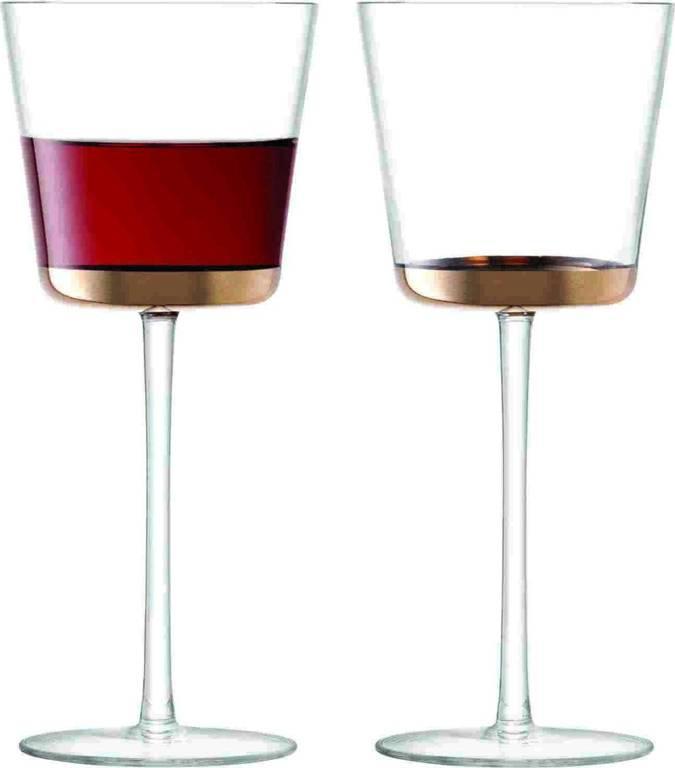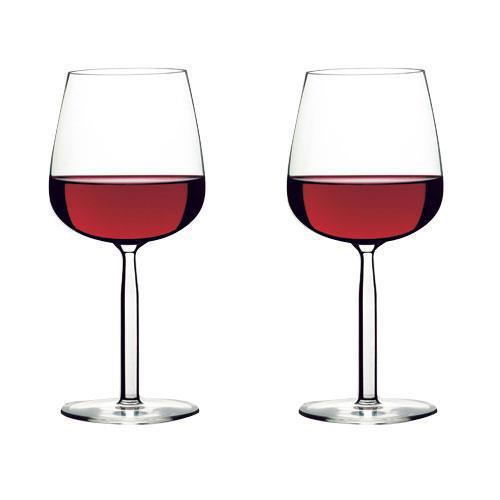The first image is the image on the left, the second image is the image on the right. Given the left and right images, does the statement "There is at least two wine glasses in the right image." hold true? Answer yes or no. Yes. 